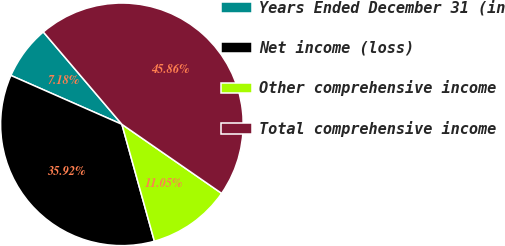Convert chart to OTSL. <chart><loc_0><loc_0><loc_500><loc_500><pie_chart><fcel>Years Ended December 31 (in<fcel>Net income (loss)<fcel>Other comprehensive income<fcel>Total comprehensive income<nl><fcel>7.18%<fcel>35.92%<fcel>11.05%<fcel>45.86%<nl></chart> 